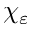<formula> <loc_0><loc_0><loc_500><loc_500>\chi _ { \varepsilon }</formula> 